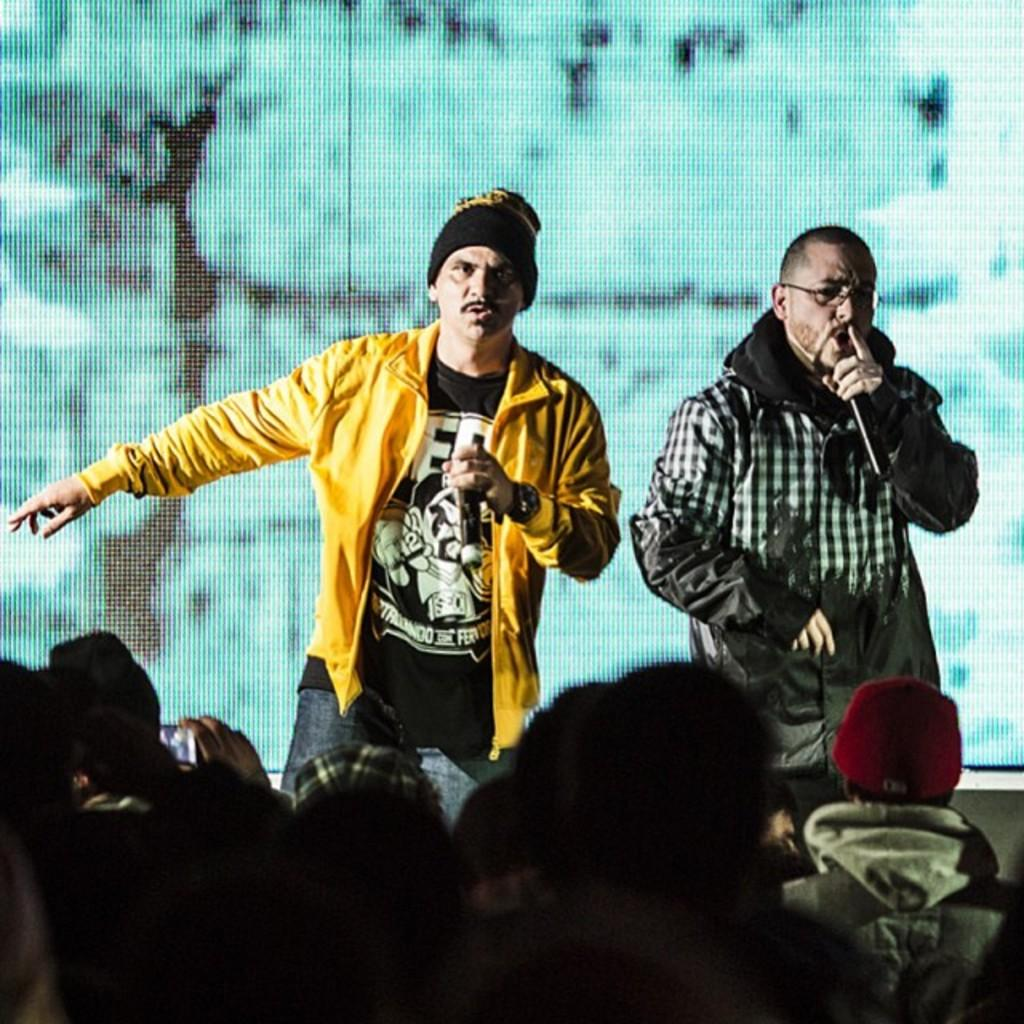What are the two people in the image holding? The two people in the image are holding microphones. What might be happening in the image? It appears that the two people holding microphones are addressing or performing for the group of people sitting in front of them. What type of crack can be seen in the image? There is no crack present in the image. Is it raining in the image? There is no indication of rain in the image. 